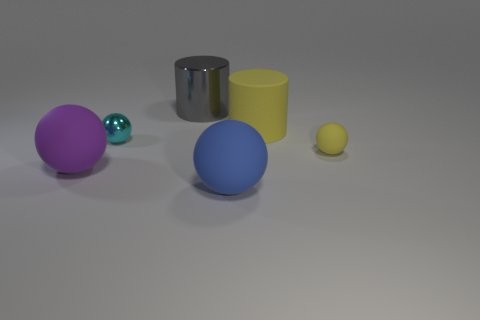Add 2 purple objects. How many objects exist? 8 Subtract all balls. How many objects are left? 2 Add 3 metallic objects. How many metallic objects are left? 5 Add 1 brown shiny cylinders. How many brown shiny cylinders exist? 1 Subtract 0 cyan cubes. How many objects are left? 6 Subtract all blue balls. Subtract all large cylinders. How many objects are left? 3 